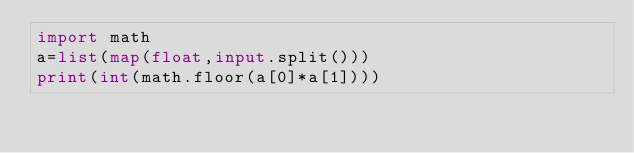Convert code to text. <code><loc_0><loc_0><loc_500><loc_500><_Python_>import math
a=list(map(float,input.split()))
print(int(math.floor(a[0]*a[1])))</code> 